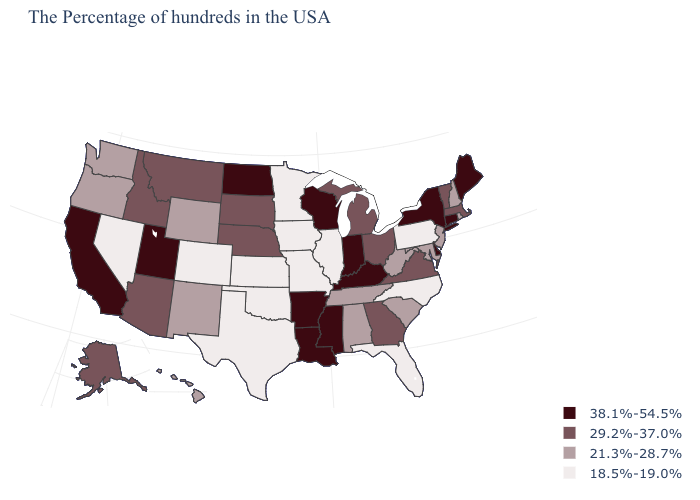Which states have the lowest value in the West?
Be succinct. Colorado, Nevada. Is the legend a continuous bar?
Write a very short answer. No. Does Minnesota have the lowest value in the MidWest?
Be succinct. Yes. Does Colorado have a lower value than Idaho?
Keep it brief. Yes. Name the states that have a value in the range 29.2%-37.0%?
Be succinct. Massachusetts, Vermont, Virginia, Ohio, Georgia, Michigan, Nebraska, South Dakota, Montana, Arizona, Idaho, Alaska. What is the value of Massachusetts?
Give a very brief answer. 29.2%-37.0%. What is the value of Kentucky?
Give a very brief answer. 38.1%-54.5%. What is the lowest value in the USA?
Short answer required. 18.5%-19.0%. Name the states that have a value in the range 21.3%-28.7%?
Keep it brief. Rhode Island, New Hampshire, New Jersey, Maryland, South Carolina, West Virginia, Alabama, Tennessee, Wyoming, New Mexico, Washington, Oregon, Hawaii. Which states have the lowest value in the USA?
Be succinct. Pennsylvania, North Carolina, Florida, Illinois, Missouri, Minnesota, Iowa, Kansas, Oklahoma, Texas, Colorado, Nevada. Is the legend a continuous bar?
Concise answer only. No. What is the value of Michigan?
Keep it brief. 29.2%-37.0%. What is the lowest value in states that border Texas?
Be succinct. 18.5%-19.0%. Among the states that border Massachusetts , which have the highest value?
Short answer required. Connecticut, New York. Which states have the lowest value in the MidWest?
Answer briefly. Illinois, Missouri, Minnesota, Iowa, Kansas. 